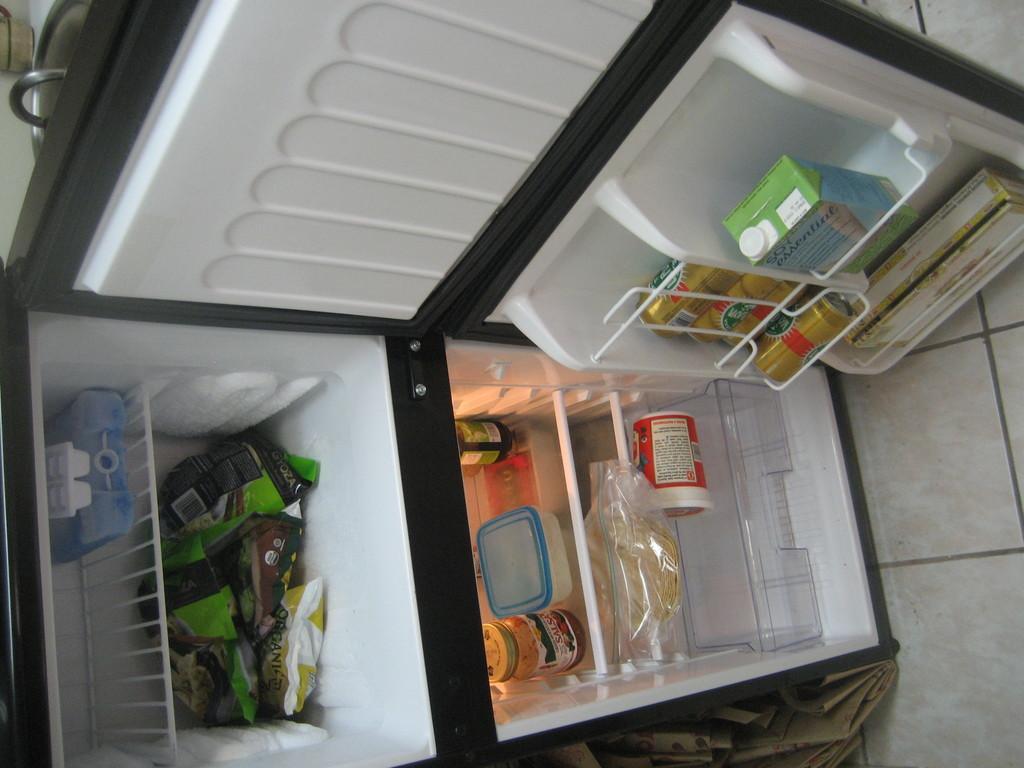Describe this image in one or two sentences. In this rotated image there is a refrigerator. The door of the refrigerator is open. Inside the refrigerator there are food packets, boxes, drink cans and jars. TO the right there is the floor. 